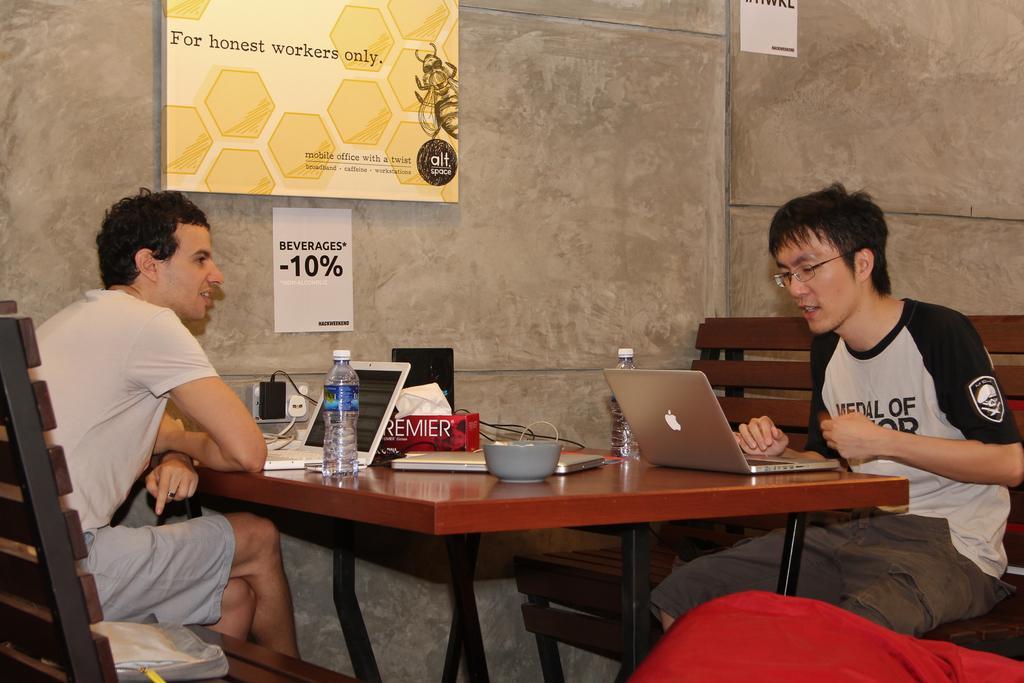How would you summarize this image in a sentence or two? In the background we can see a board and paper notes on the wall. In this picture we can see the men wearing t-shirts and they both are sitting on the benches. On a bench we can see a bag. On a table we can see water bottles, tissue paper box, laptops, bowl. We can see a socket and a wire. At the bottom portion of the picture it looks like a leg of a person wearing a red pant. 